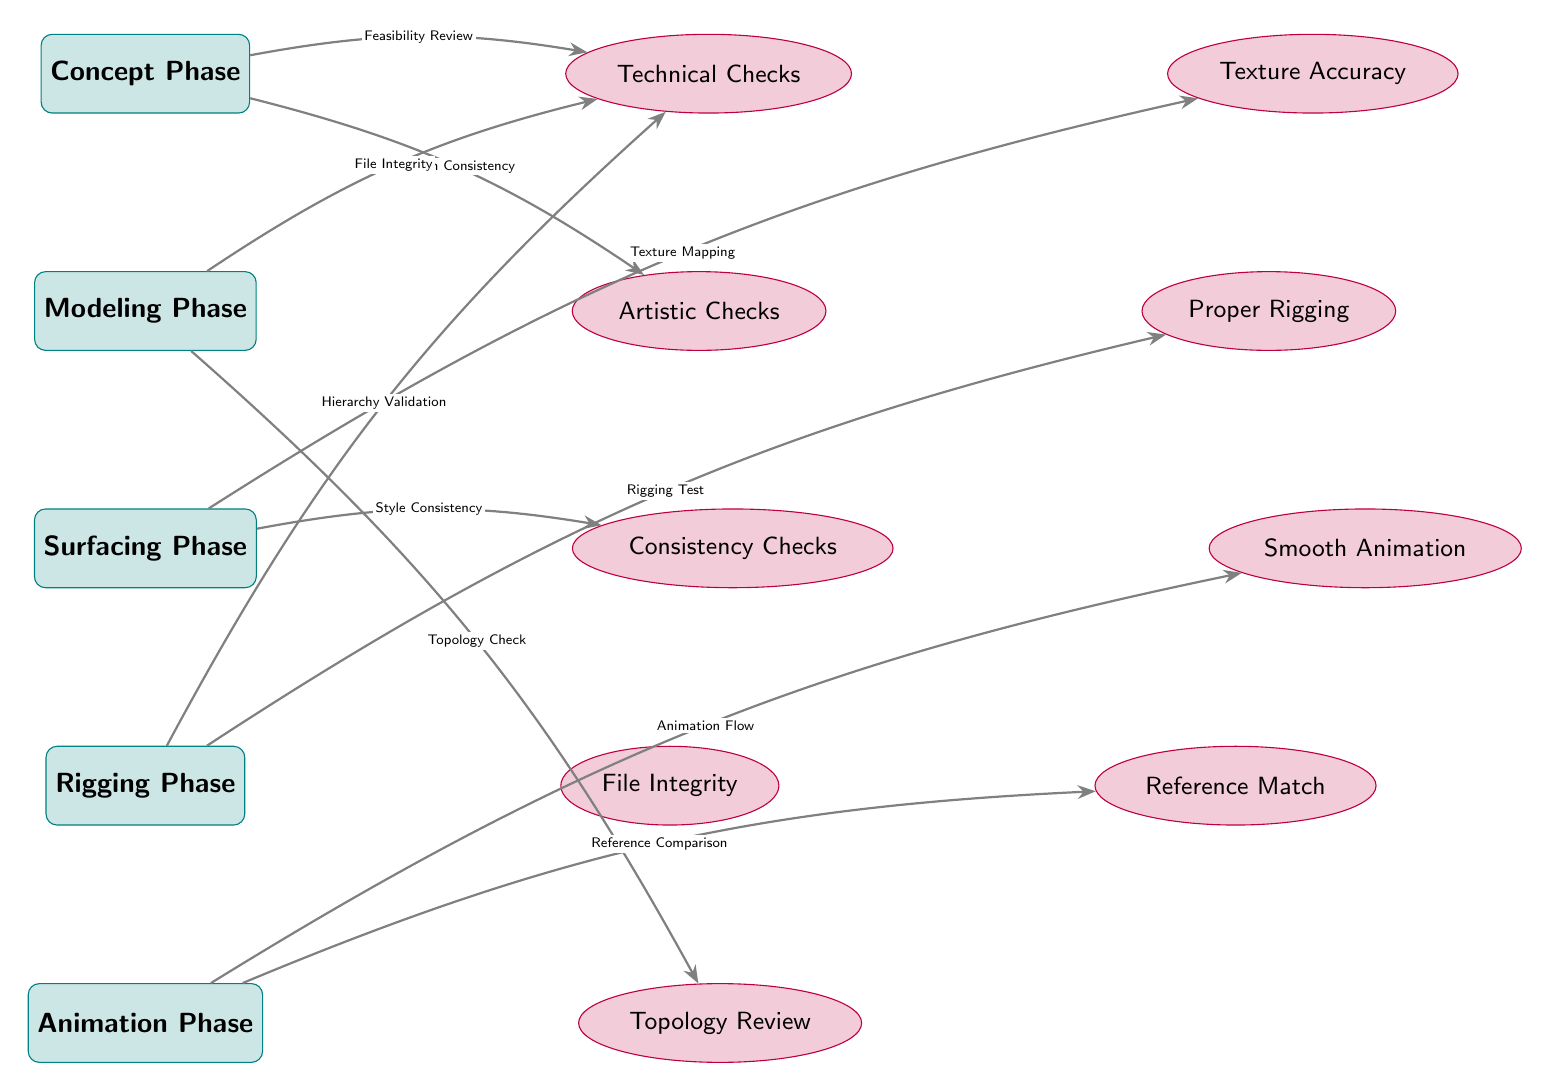What are the names of the phases in the diagram? The diagram lists five phases: Concept Phase, Modeling Phase, Surfacing Phase, Rigging Phase, and Animation Phase. Each phase is clearly labeled in the diagram.
Answer: Concept Phase, Modeling Phase, Surfacing Phase, Rigging Phase, Animation Phase How many checks are listed in the diagram? The diagram contains five checks: Technical Checks, Artistic Checks, Consistency Checks, File Integrity, and Topology Review. This can be determined by counting the check nodes.
Answer: Five Which phase has a connection to the texture accuracy check? The Surfacing Phase connects to the Texture Accuracy check, as shown by the arrow indicating the relationship between the two nodes.
Answer: Surfacing Phase What is the purpose of the connection between the modeling phase and the topology review? The connection indicates that a Topology Check is required after the Modeling Phase, as depicted by the arrow between these two elements in the diagram.
Answer: Topology Check Which check is associated with the animation phase? The Animation Phase is connected to two checks: Smooth Animation and Reference Match, highlighting the specific checks performed after this phase.
Answer: Smooth Animation, Reference Match What type of review is linked to the concept phase and technical checks? A Feasibility Review is the type of review connected to the Concept Phase and Technical Checks, showing the critical link between the initial phase and the technical aspect of the pipeline.
Answer: Feasibility Review Explain the relationship between file integrity and the rigging phase. The Rigging Phase has a connection to Technical Checks through the Hierarchy Validation, and the File Integrity check is also linked to the Modeling Phase. While both checks relate to maintaining the integrity, they arise from different phases.
Answer: Hierarchy Validation What is the primary focus of the checks following the surfacing phase? The checks following the Surfacing Phase focus on texture accuracy and consistency, indicating that these elements are essential for quality control after surfacing.
Answer: Texture Accuracy, Consistency Checks 